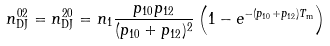Convert formula to latex. <formula><loc_0><loc_0><loc_500><loc_500>n _ { \text {DJ} } ^ { 0 2 } = n _ { \text {DJ} } ^ { 2 0 } = n _ { 1 } \frac { p _ { 1 0 } p _ { 1 2 } } { ( p _ { 1 0 } + p _ { 1 2 } ) ^ { 2 } } \left ( 1 - e ^ { - ( p _ { 1 0 } + p _ { 1 2 } ) T _ { \text {m} } } \right )</formula> 